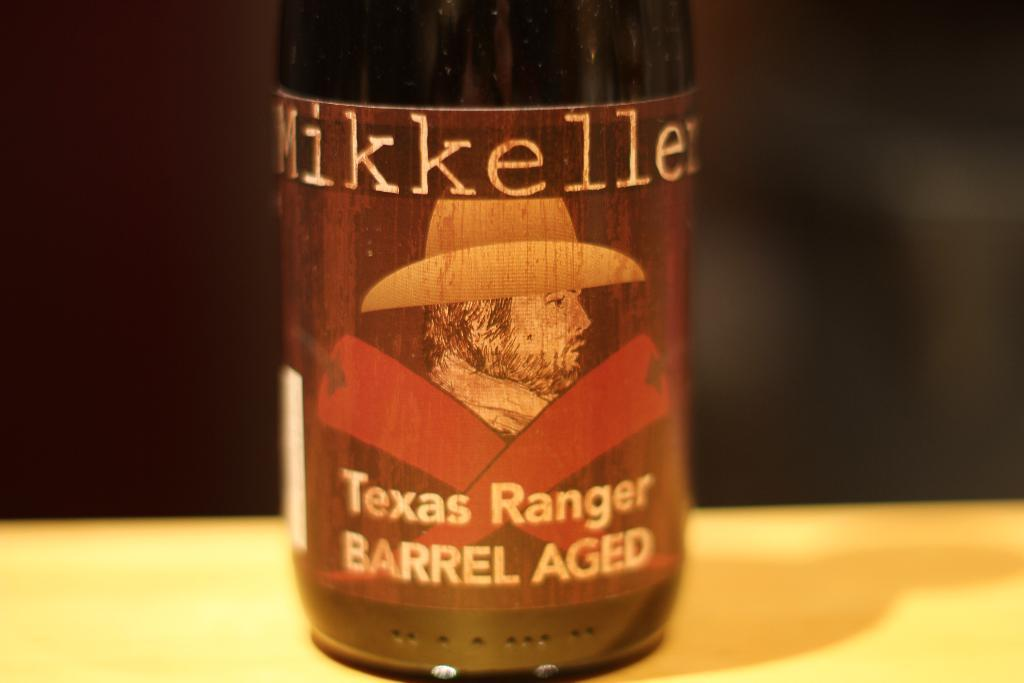<image>
Summarize the visual content of the image. A brown bottle shows its label saying it's barrel aged. 